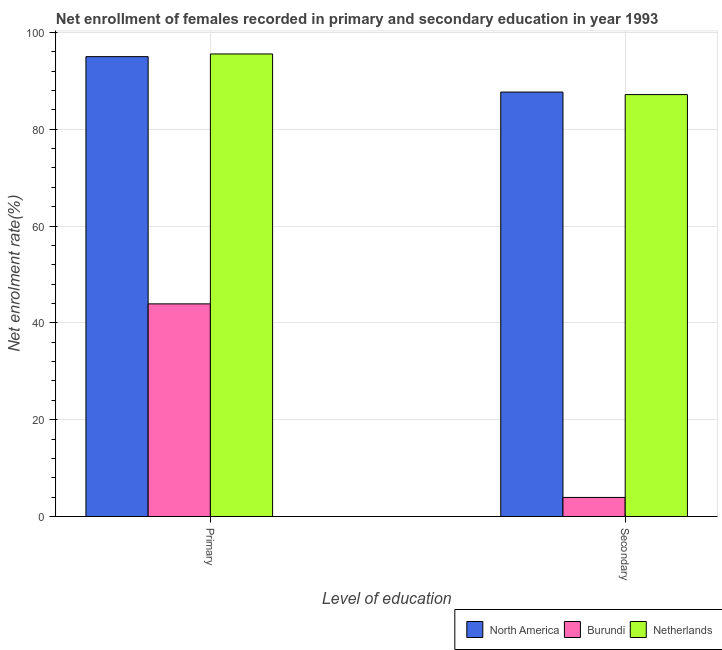Are the number of bars on each tick of the X-axis equal?
Give a very brief answer. Yes. How many bars are there on the 1st tick from the right?
Provide a short and direct response. 3. What is the label of the 1st group of bars from the left?
Provide a succinct answer. Primary. What is the enrollment rate in secondary education in North America?
Give a very brief answer. 87.68. Across all countries, what is the maximum enrollment rate in secondary education?
Keep it short and to the point. 87.68. Across all countries, what is the minimum enrollment rate in secondary education?
Your answer should be very brief. 3.94. In which country was the enrollment rate in primary education maximum?
Your response must be concise. Netherlands. In which country was the enrollment rate in primary education minimum?
Offer a terse response. Burundi. What is the total enrollment rate in secondary education in the graph?
Provide a succinct answer. 178.78. What is the difference between the enrollment rate in primary education in North America and that in Netherlands?
Offer a terse response. -0.56. What is the difference between the enrollment rate in secondary education in North America and the enrollment rate in primary education in Netherlands?
Your answer should be compact. -7.87. What is the average enrollment rate in secondary education per country?
Provide a short and direct response. 59.59. What is the difference between the enrollment rate in primary education and enrollment rate in secondary education in North America?
Keep it short and to the point. 7.32. In how many countries, is the enrollment rate in secondary education greater than 32 %?
Keep it short and to the point. 2. What is the ratio of the enrollment rate in secondary education in Netherlands to that in North America?
Your answer should be very brief. 0.99. In how many countries, is the enrollment rate in primary education greater than the average enrollment rate in primary education taken over all countries?
Your response must be concise. 2. What does the 3rd bar from the left in Primary represents?
Ensure brevity in your answer.  Netherlands. What does the 2nd bar from the right in Primary represents?
Provide a short and direct response. Burundi. How many bars are there?
Offer a very short reply. 6. Are all the bars in the graph horizontal?
Your answer should be very brief. No. How many countries are there in the graph?
Your answer should be very brief. 3. What is the difference between two consecutive major ticks on the Y-axis?
Make the answer very short. 20. Where does the legend appear in the graph?
Ensure brevity in your answer.  Bottom right. How many legend labels are there?
Give a very brief answer. 3. How are the legend labels stacked?
Offer a terse response. Horizontal. What is the title of the graph?
Give a very brief answer. Net enrollment of females recorded in primary and secondary education in year 1993. Does "Netherlands" appear as one of the legend labels in the graph?
Provide a succinct answer. Yes. What is the label or title of the X-axis?
Offer a terse response. Level of education. What is the label or title of the Y-axis?
Provide a succinct answer. Net enrolment rate(%). What is the Net enrolment rate(%) in North America in Primary?
Offer a very short reply. 95. What is the Net enrolment rate(%) in Burundi in Primary?
Make the answer very short. 43.93. What is the Net enrolment rate(%) in Netherlands in Primary?
Provide a succinct answer. 95.55. What is the Net enrolment rate(%) in North America in Secondary?
Give a very brief answer. 87.68. What is the Net enrolment rate(%) of Burundi in Secondary?
Keep it short and to the point. 3.94. What is the Net enrolment rate(%) in Netherlands in Secondary?
Ensure brevity in your answer.  87.16. Across all Level of education, what is the maximum Net enrolment rate(%) of North America?
Your answer should be very brief. 95. Across all Level of education, what is the maximum Net enrolment rate(%) in Burundi?
Your answer should be compact. 43.93. Across all Level of education, what is the maximum Net enrolment rate(%) of Netherlands?
Provide a succinct answer. 95.55. Across all Level of education, what is the minimum Net enrolment rate(%) in North America?
Make the answer very short. 87.68. Across all Level of education, what is the minimum Net enrolment rate(%) of Burundi?
Keep it short and to the point. 3.94. Across all Level of education, what is the minimum Net enrolment rate(%) of Netherlands?
Provide a short and direct response. 87.16. What is the total Net enrolment rate(%) of North America in the graph?
Provide a short and direct response. 182.67. What is the total Net enrolment rate(%) of Burundi in the graph?
Make the answer very short. 47.87. What is the total Net enrolment rate(%) in Netherlands in the graph?
Your response must be concise. 182.71. What is the difference between the Net enrolment rate(%) in North America in Primary and that in Secondary?
Provide a succinct answer. 7.32. What is the difference between the Net enrolment rate(%) of Burundi in Primary and that in Secondary?
Ensure brevity in your answer.  39.98. What is the difference between the Net enrolment rate(%) of Netherlands in Primary and that in Secondary?
Offer a terse response. 8.39. What is the difference between the Net enrolment rate(%) of North America in Primary and the Net enrolment rate(%) of Burundi in Secondary?
Your answer should be compact. 91.05. What is the difference between the Net enrolment rate(%) of North America in Primary and the Net enrolment rate(%) of Netherlands in Secondary?
Ensure brevity in your answer.  7.84. What is the difference between the Net enrolment rate(%) in Burundi in Primary and the Net enrolment rate(%) in Netherlands in Secondary?
Make the answer very short. -43.23. What is the average Net enrolment rate(%) of North America per Level of education?
Your response must be concise. 91.34. What is the average Net enrolment rate(%) in Burundi per Level of education?
Your answer should be very brief. 23.94. What is the average Net enrolment rate(%) of Netherlands per Level of education?
Offer a very short reply. 91.36. What is the difference between the Net enrolment rate(%) of North America and Net enrolment rate(%) of Burundi in Primary?
Ensure brevity in your answer.  51.07. What is the difference between the Net enrolment rate(%) in North America and Net enrolment rate(%) in Netherlands in Primary?
Make the answer very short. -0.56. What is the difference between the Net enrolment rate(%) in Burundi and Net enrolment rate(%) in Netherlands in Primary?
Your answer should be compact. -51.63. What is the difference between the Net enrolment rate(%) of North America and Net enrolment rate(%) of Burundi in Secondary?
Keep it short and to the point. 83.73. What is the difference between the Net enrolment rate(%) of North America and Net enrolment rate(%) of Netherlands in Secondary?
Your answer should be compact. 0.52. What is the difference between the Net enrolment rate(%) in Burundi and Net enrolment rate(%) in Netherlands in Secondary?
Ensure brevity in your answer.  -83.21. What is the ratio of the Net enrolment rate(%) of North America in Primary to that in Secondary?
Offer a terse response. 1.08. What is the ratio of the Net enrolment rate(%) in Burundi in Primary to that in Secondary?
Make the answer very short. 11.14. What is the ratio of the Net enrolment rate(%) of Netherlands in Primary to that in Secondary?
Your answer should be very brief. 1.1. What is the difference between the highest and the second highest Net enrolment rate(%) in North America?
Offer a terse response. 7.32. What is the difference between the highest and the second highest Net enrolment rate(%) of Burundi?
Give a very brief answer. 39.98. What is the difference between the highest and the second highest Net enrolment rate(%) in Netherlands?
Your response must be concise. 8.39. What is the difference between the highest and the lowest Net enrolment rate(%) of North America?
Your response must be concise. 7.32. What is the difference between the highest and the lowest Net enrolment rate(%) of Burundi?
Give a very brief answer. 39.98. What is the difference between the highest and the lowest Net enrolment rate(%) of Netherlands?
Your response must be concise. 8.39. 